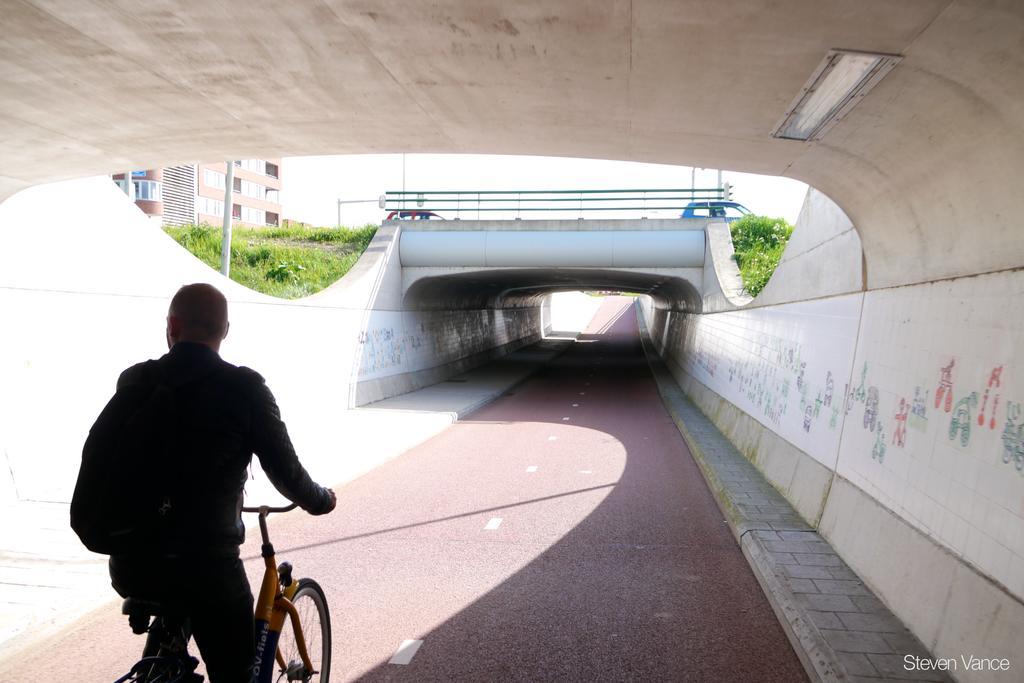How would you summarize this image in a sentence or two? In this image I can see a person on his cycle and he is also carrying a bag. In the background I can see few vehicles, grass and a building. 